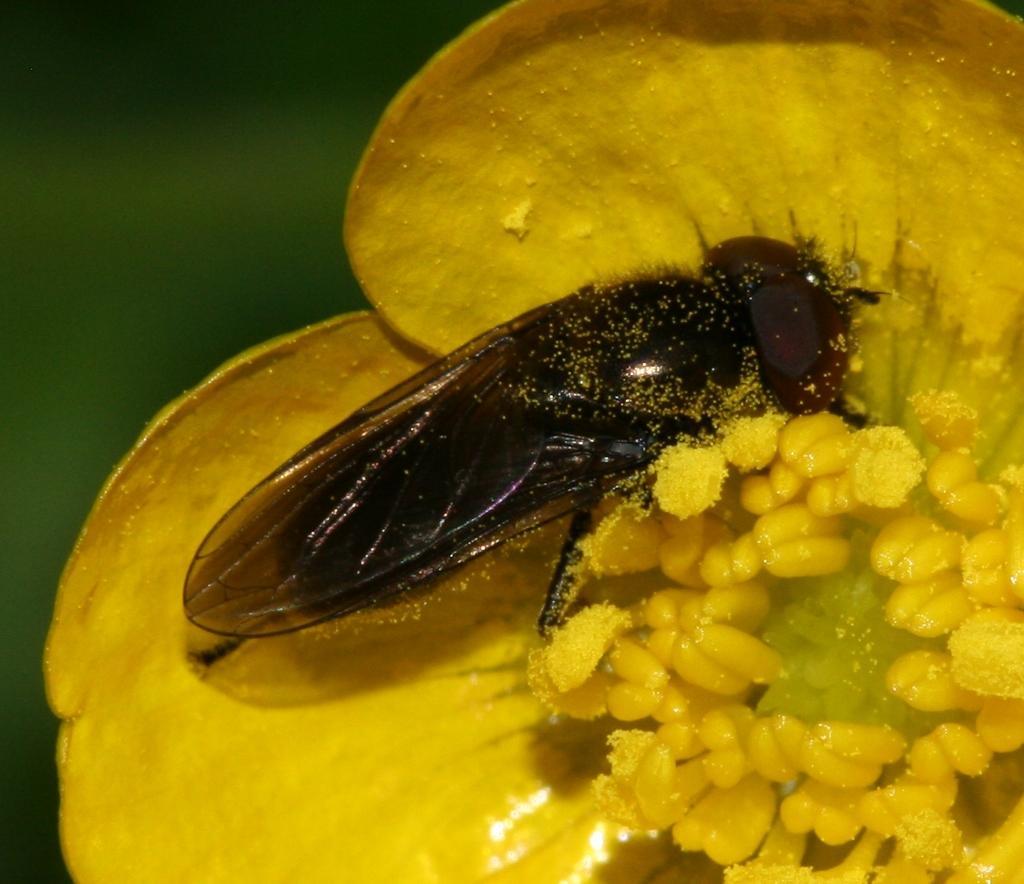Can you describe this image briefly? In this image there is an insect on a yellow color flower, and there is blur background. 